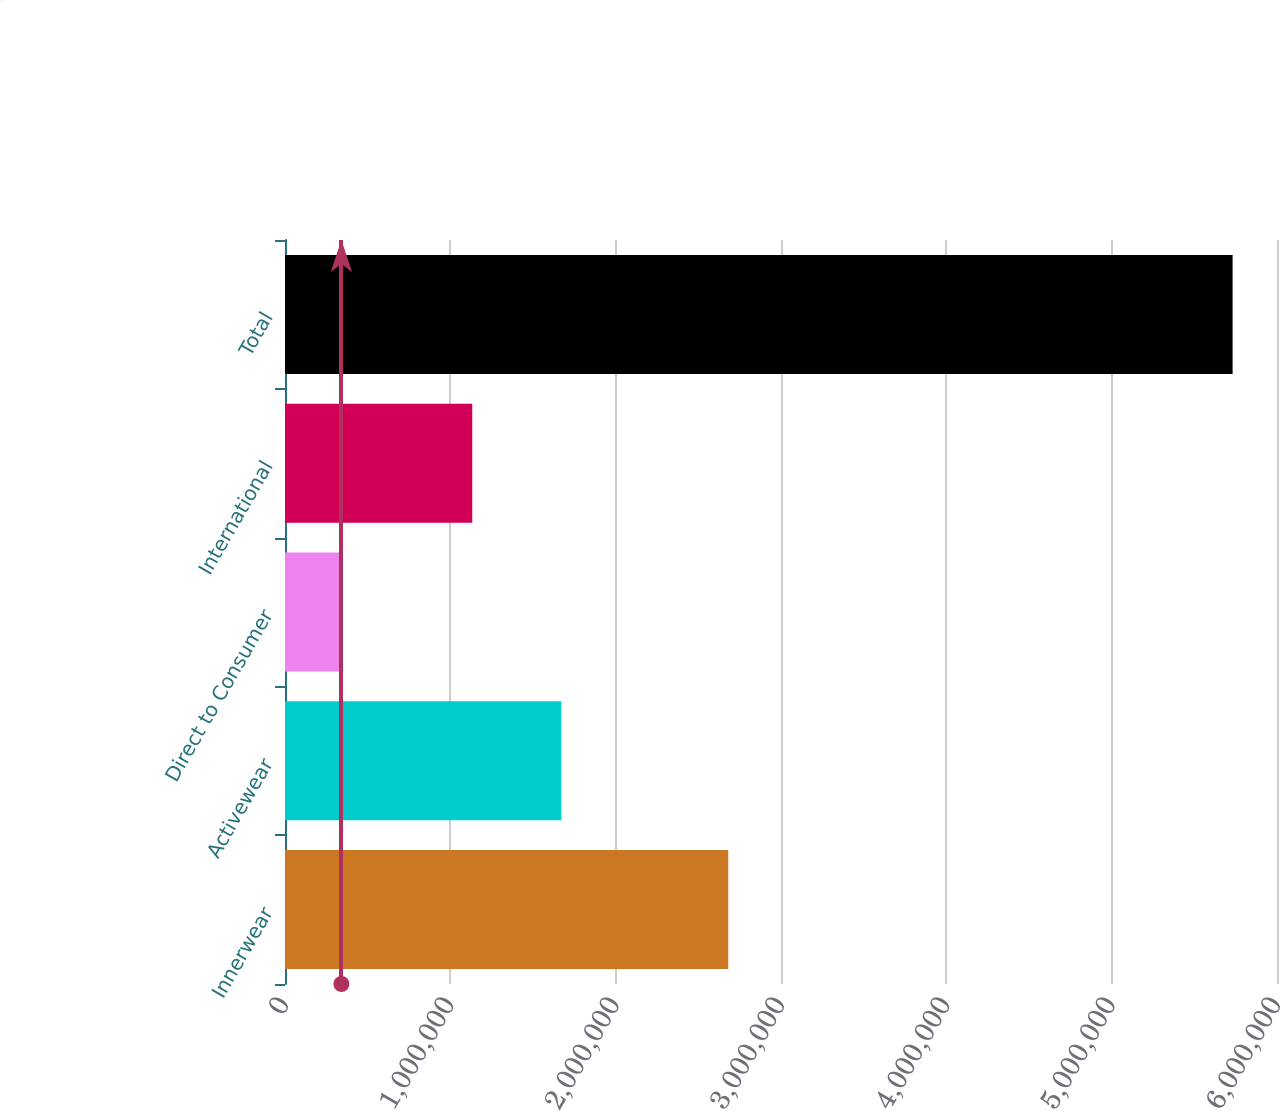Convert chart to OTSL. <chart><loc_0><loc_0><loc_500><loc_500><bar_chart><fcel>Innerwear<fcel>Activewear<fcel>Direct to Consumer<fcel>International<fcel>Total<nl><fcel>2.68098e+06<fcel>1.67167e+06<fcel>341207<fcel>1.13264e+06<fcel>5.73155e+06<nl></chart> 